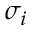Convert formula to latex. <formula><loc_0><loc_0><loc_500><loc_500>\sigma _ { i }</formula> 